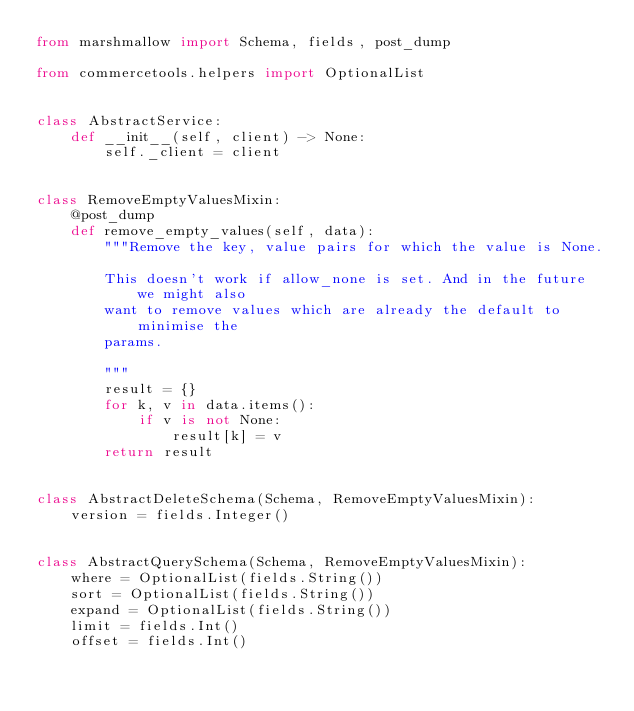Convert code to text. <code><loc_0><loc_0><loc_500><loc_500><_Python_>from marshmallow import Schema, fields, post_dump

from commercetools.helpers import OptionalList


class AbstractService:
    def __init__(self, client) -> None:
        self._client = client


class RemoveEmptyValuesMixin:
    @post_dump
    def remove_empty_values(self, data):
        """Remove the key, value pairs for which the value is None.

        This doesn't work if allow_none is set. And in the future we might also
        want to remove values which are already the default to minimise the
        params.

        """
        result = {}
        for k, v in data.items():
            if v is not None:
                result[k] = v
        return result


class AbstractDeleteSchema(Schema, RemoveEmptyValuesMixin):
    version = fields.Integer()


class AbstractQuerySchema(Schema, RemoveEmptyValuesMixin):
    where = OptionalList(fields.String())
    sort = OptionalList(fields.String())
    expand = OptionalList(fields.String())
    limit = fields.Int()
    offset = fields.Int()
</code> 